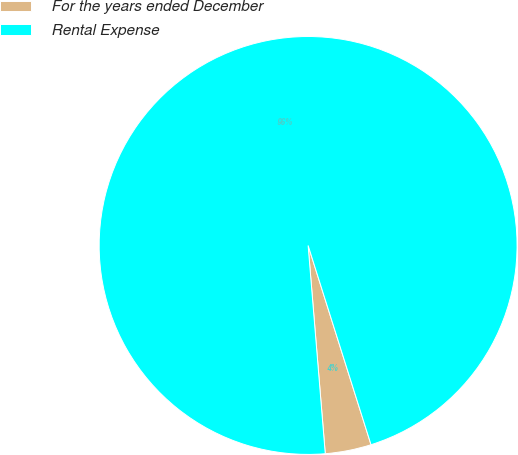Convert chart. <chart><loc_0><loc_0><loc_500><loc_500><pie_chart><fcel>For the years ended December<fcel>Rental Expense<nl><fcel>3.56%<fcel>96.44%<nl></chart> 